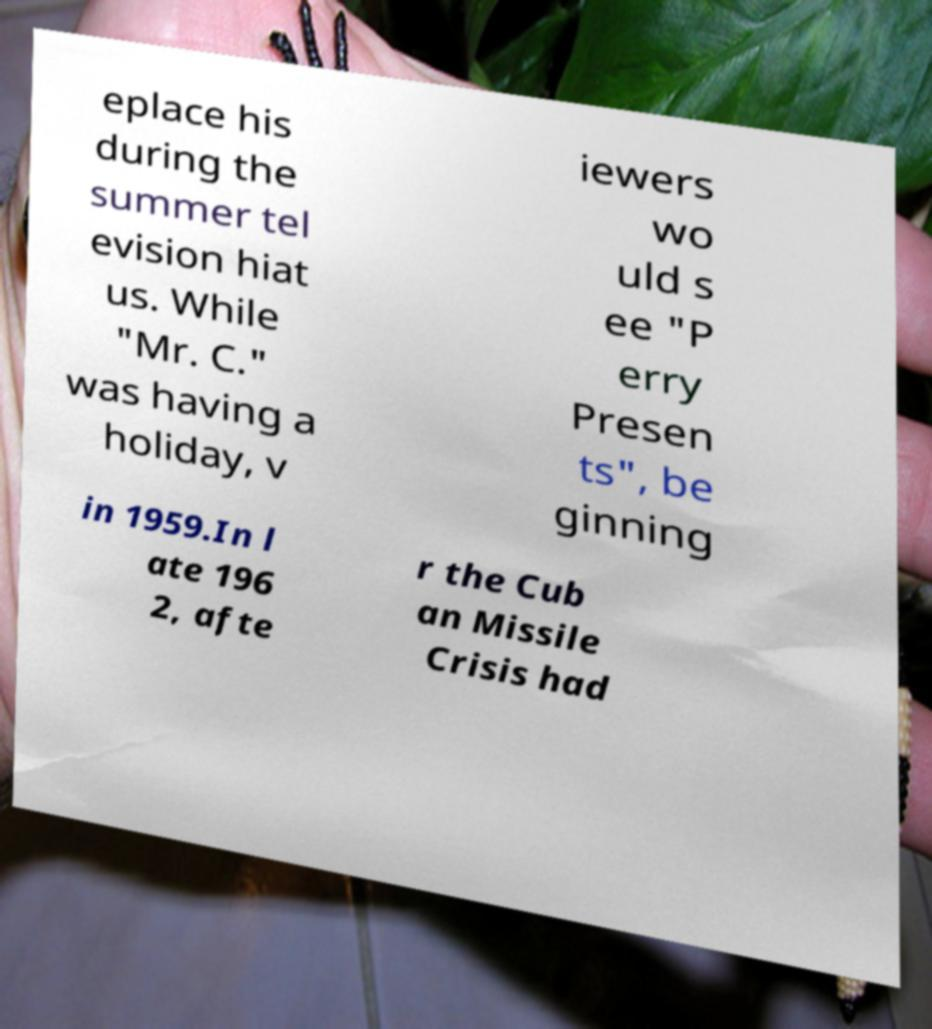Please identify and transcribe the text found in this image. eplace his during the summer tel evision hiat us. While "Mr. C." was having a holiday, v iewers wo uld s ee "P erry Presen ts", be ginning in 1959.In l ate 196 2, afte r the Cub an Missile Crisis had 